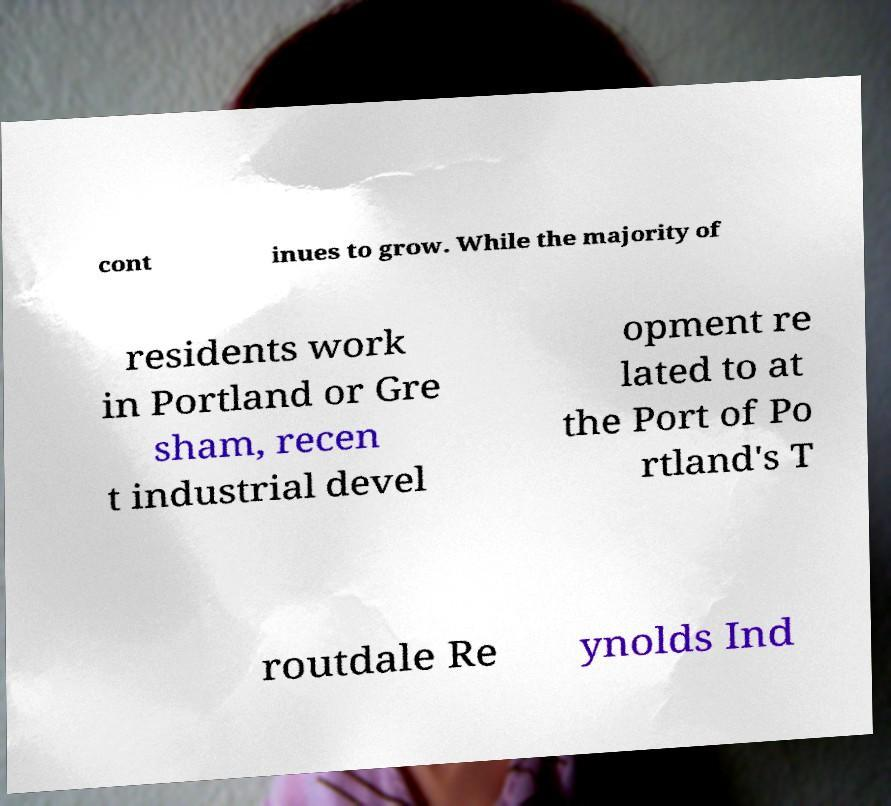For documentation purposes, I need the text within this image transcribed. Could you provide that? cont inues to grow. While the majority of residents work in Portland or Gre sham, recen t industrial devel opment re lated to at the Port of Po rtland's T routdale Re ynolds Ind 